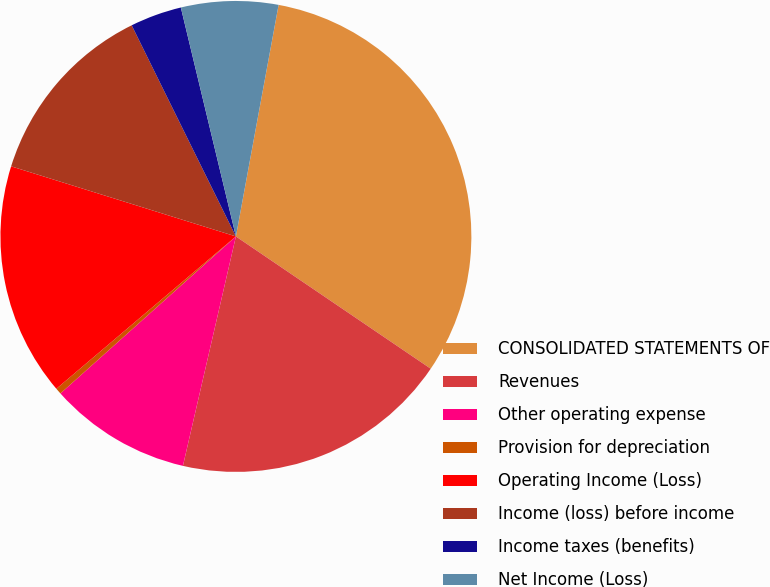<chart> <loc_0><loc_0><loc_500><loc_500><pie_chart><fcel>CONSOLIDATED STATEMENTS OF<fcel>Revenues<fcel>Other operating expense<fcel>Provision for depreciation<fcel>Operating Income (Loss)<fcel>Income (loss) before income<fcel>Income taxes (benefits)<fcel>Net Income (Loss)<nl><fcel>31.59%<fcel>19.12%<fcel>9.77%<fcel>0.42%<fcel>16.01%<fcel>12.89%<fcel>3.54%<fcel>6.66%<nl></chart> 